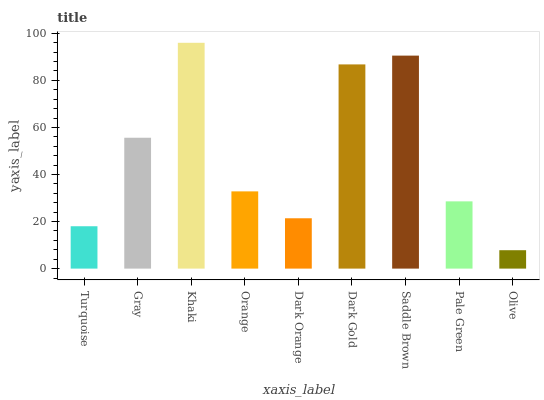Is Olive the minimum?
Answer yes or no. Yes. Is Khaki the maximum?
Answer yes or no. Yes. Is Gray the minimum?
Answer yes or no. No. Is Gray the maximum?
Answer yes or no. No. Is Gray greater than Turquoise?
Answer yes or no. Yes. Is Turquoise less than Gray?
Answer yes or no. Yes. Is Turquoise greater than Gray?
Answer yes or no. No. Is Gray less than Turquoise?
Answer yes or no. No. Is Orange the high median?
Answer yes or no. Yes. Is Orange the low median?
Answer yes or no. Yes. Is Dark Gold the high median?
Answer yes or no. No. Is Turquoise the low median?
Answer yes or no. No. 